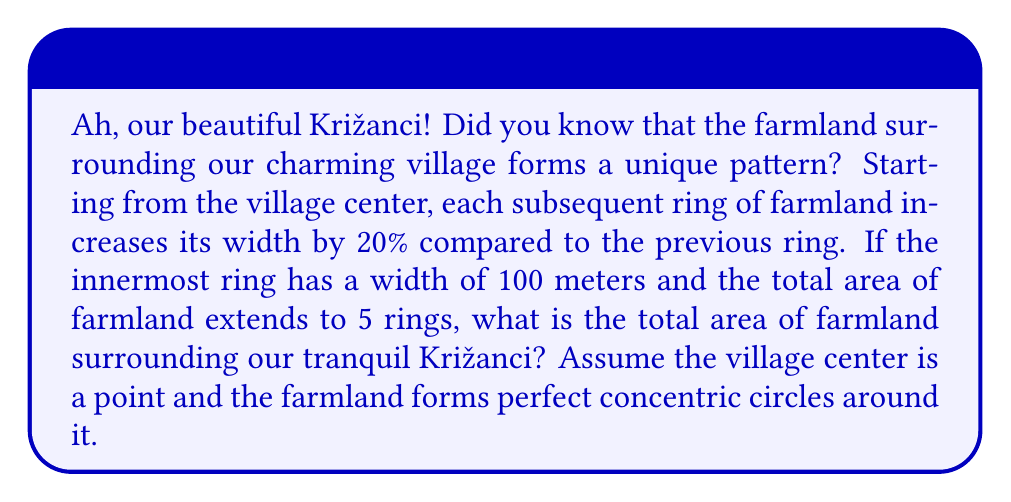Can you answer this question? Let's approach this step-by-step, showcasing the mathematical beauty hidden in our Križanci's landscape!

1) First, let's define our geometric series. The width of each ring forms a geometric sequence with:
   $a = 100$ (first term)
   $r = 1.2$ (common ratio, as each ring is 20% wider than the previous)

2) The widths of the 5 rings are:
   Ring 1: $100$ m
   Ring 2: $100 \cdot 1.2 = 120$ m
   Ring 3: $100 \cdot 1.2^2 = 144$ m
   Ring 4: $100 \cdot 1.2^3 = 172.8$ m
   Ring 5: $100 \cdot 1.2^4 = 207.36$ m

3) To find the area, we need to calculate the radius to the outer edge of each ring:
   $R_1 = 100$
   $R_2 = 100 + 120 = 220$
   $R_3 = 100 + 120 + 144 = 364$
   $R_4 = 100 + 120 + 144 + 172.8 = 536.8$
   $R_5 = 100 + 120 + 144 + 172.8 + 207.36 = 744.16$

4) The area of each ring is the difference between the areas of the circles formed by its outer and inner radii:
   $A_1 = \pi R_1^2 = \pi \cdot 100^2 = 10000\pi$
   $A_2 = \pi (R_2^2 - R_1^2) = \pi (220^2 - 100^2) = 38400\pi$
   $A_3 = \pi (R_3^2 - R_2^2) = \pi (364^2 - 220^2) = 73984\pi$
   $A_4 = \pi (R_4^2 - R_3^2) = \pi (536.8^2 - 364^2) = 121651.2\pi$
   $A_5 = \pi (R_5^2 - R_4^2) = \pi (744.16^2 - 536.8^2) = 189644.8\pi$

5) The total area is the sum of these individual ring areas:
   $A_{total} = (10000 + 38400 + 73984 + 121651.2 + 189644.8)\pi$
              $= 433680\pi$ square meters

6) Converting to hectares (1 hectare = 10000 m²):
   $A_{hectares} = \frac{433680\pi}{10000} = 43.368\pi$ hectares
Answer: The total area of farmland surrounding Križanci is approximately 136.2 hectares (rounded to one decimal place). 